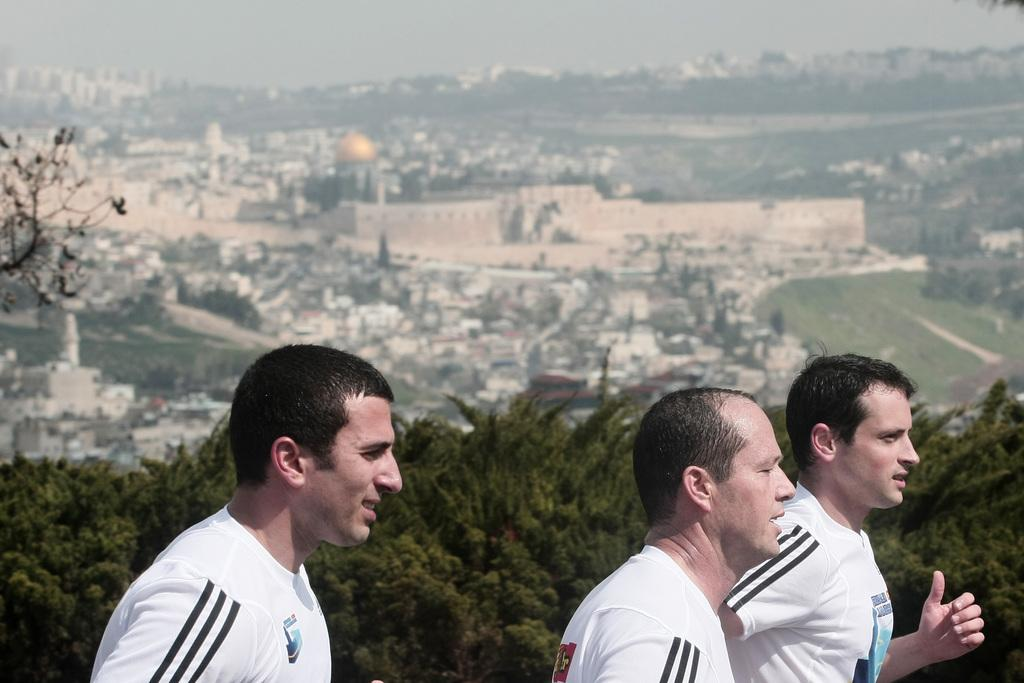How many people are in the image? There are three persons in the image. What are the people wearing? The persons are wearing white shirts. What can be seen in the background of the image? There are trees and buildings in the background of the image. What is the color of the trees? The trees are green. What is visible in the sky in the image? The sky is visible in the image and appears to be white. Can you see any salt on the persons' shirts in the image? There is no salt visible on the persons' shirts in the image. Is there a railway present in the image? There is no railway visible in the image. 